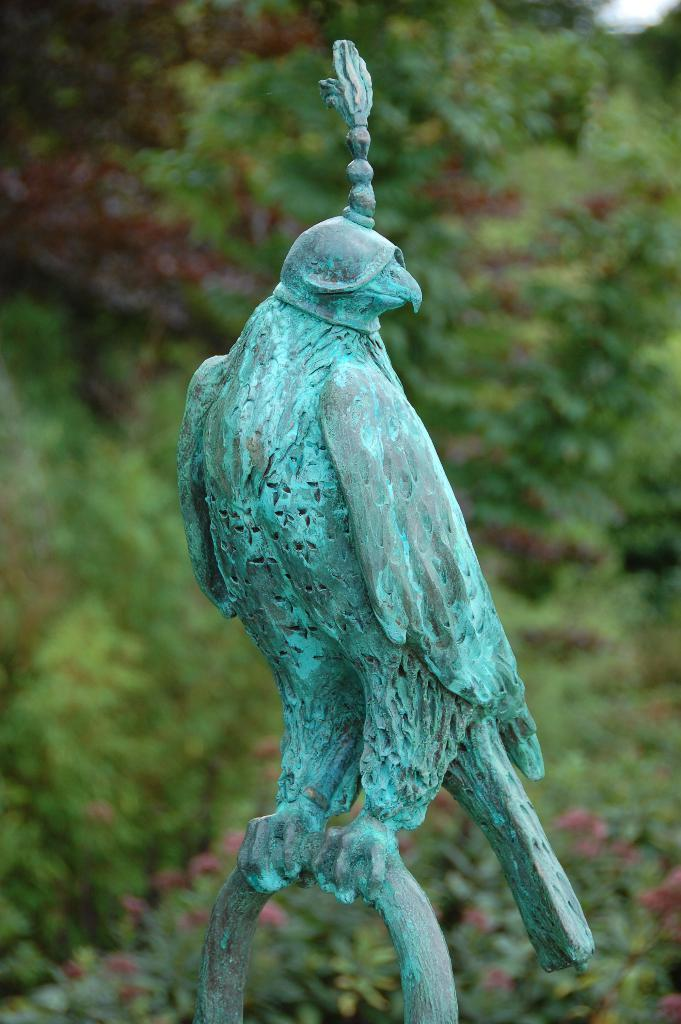What is the main subject of the image? There is a statue of a bird in the image. What is the statue standing on? The statue is standing on an object. Can you describe the background of the image? The background of the image is blurred. How many friends are playing cards in the background of the image? There are no friends or cards present in the image; it features a statue of a bird with a blurred background. 